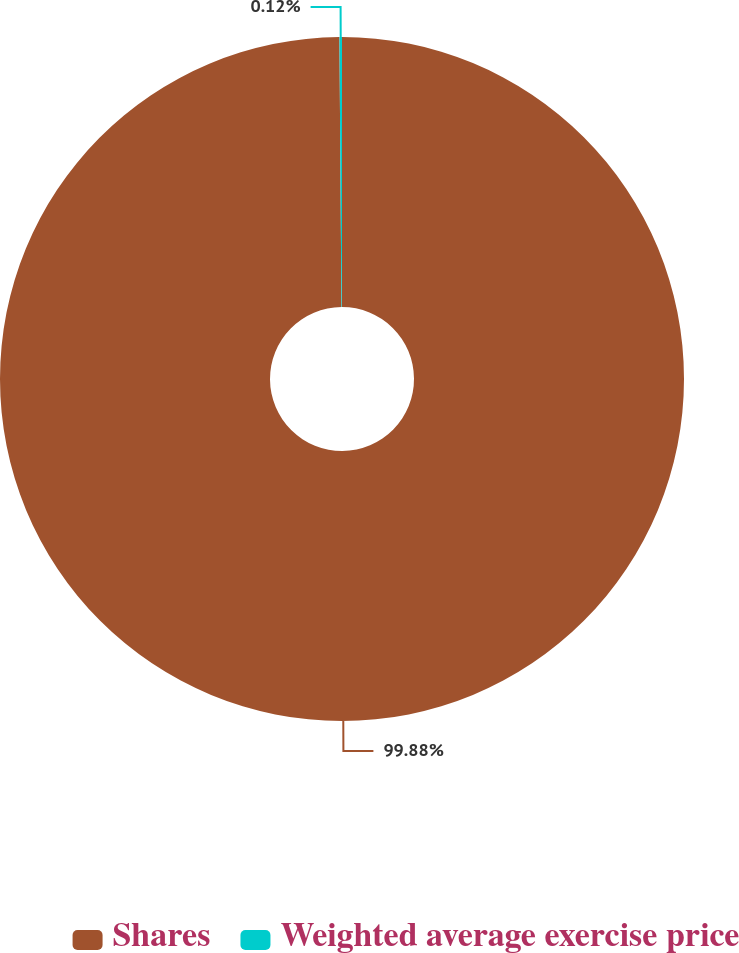<chart> <loc_0><loc_0><loc_500><loc_500><pie_chart><fcel>Shares<fcel>Weighted average exercise price<nl><fcel>99.88%<fcel>0.12%<nl></chart> 